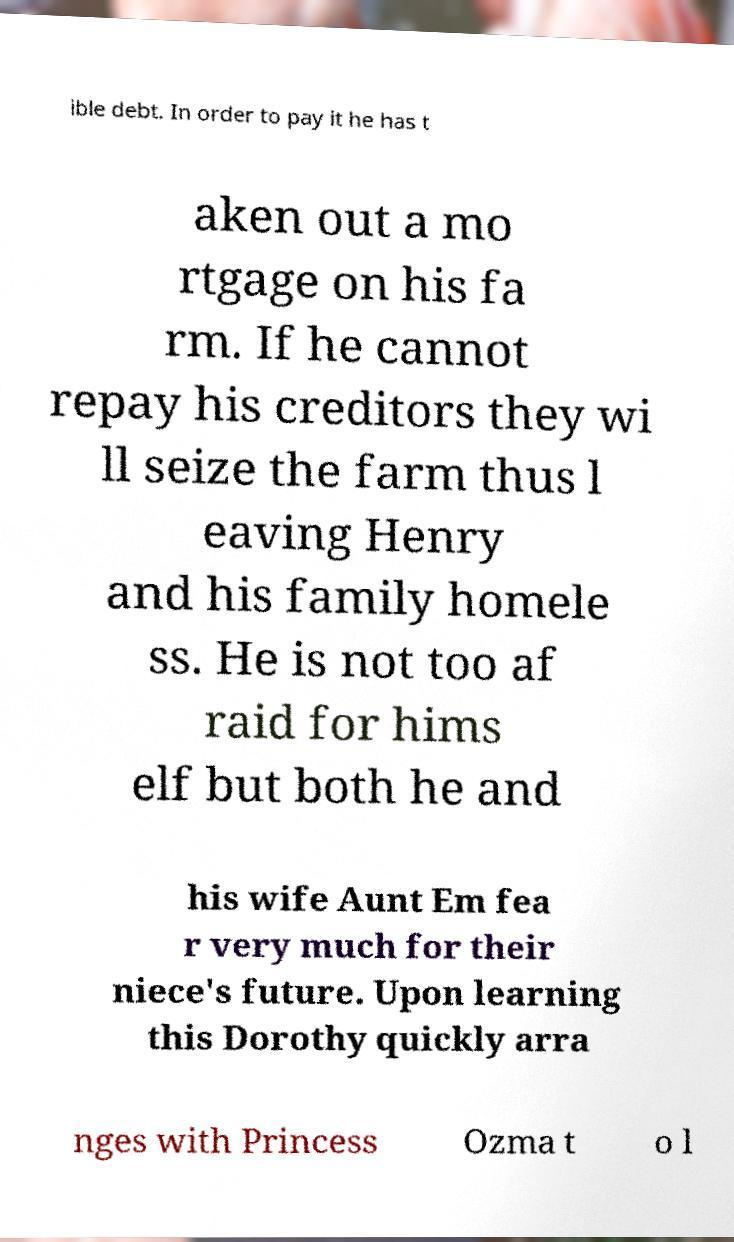I need the written content from this picture converted into text. Can you do that? ible debt. In order to pay it he has t aken out a mo rtgage on his fa rm. If he cannot repay his creditors they wi ll seize the farm thus l eaving Henry and his family homele ss. He is not too af raid for hims elf but both he and his wife Aunt Em fea r very much for their niece's future. Upon learning this Dorothy quickly arra nges with Princess Ozma t o l 